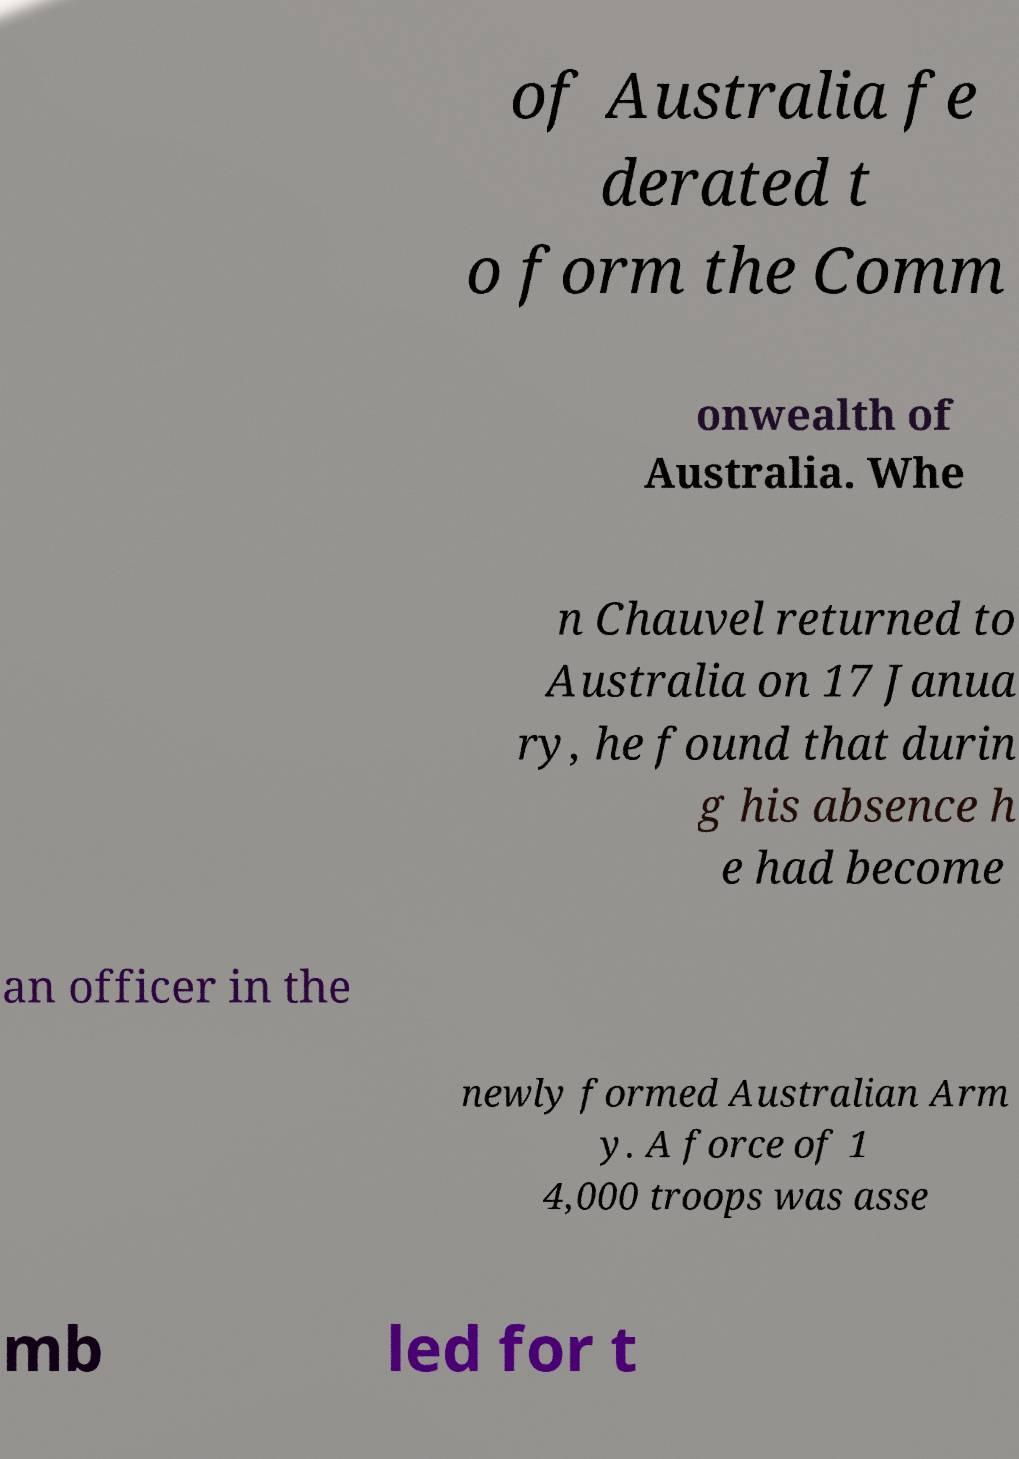Please identify and transcribe the text found in this image. of Australia fe derated t o form the Comm onwealth of Australia. Whe n Chauvel returned to Australia on 17 Janua ry, he found that durin g his absence h e had become an officer in the newly formed Australian Arm y. A force of 1 4,000 troops was asse mb led for t 